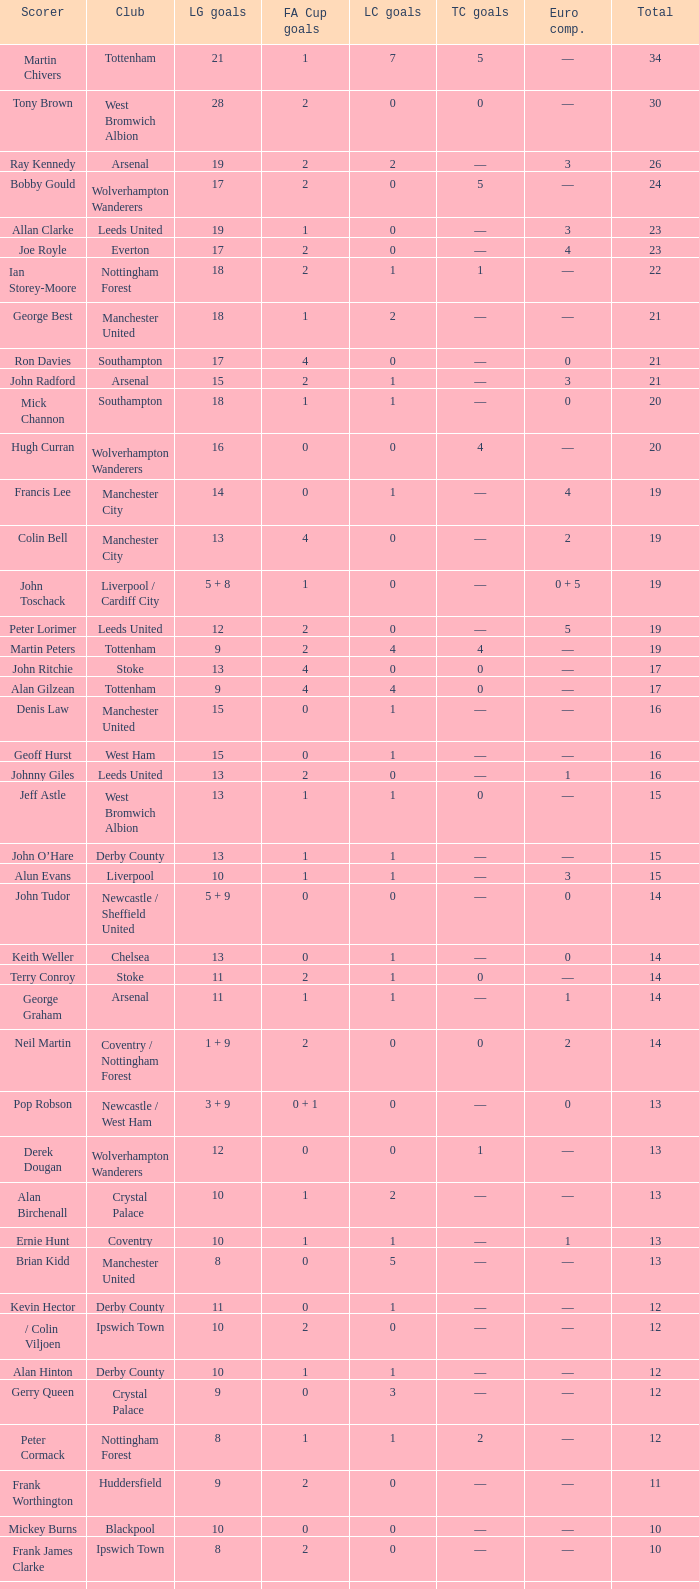Would you mind parsing the complete table? {'header': ['Scorer', 'Club', 'LG goals', 'FA Cup goals', 'LC goals', 'TC goals', 'Euro comp.', 'Total'], 'rows': [['Martin Chivers', 'Tottenham', '21', '1', '7', '5', '—', '34'], ['Tony Brown', 'West Bromwich Albion', '28', '2', '0', '0', '—', '30'], ['Ray Kennedy', 'Arsenal', '19', '2', '2', '—', '3', '26'], ['Bobby Gould', 'Wolverhampton Wanderers', '17', '2', '0', '5', '—', '24'], ['Allan Clarke', 'Leeds United', '19', '1', '0', '—', '3', '23'], ['Joe Royle', 'Everton', '17', '2', '0', '—', '4', '23'], ['Ian Storey-Moore', 'Nottingham Forest', '18', '2', '1', '1', '—', '22'], ['George Best', 'Manchester United', '18', '1', '2', '—', '—', '21'], ['Ron Davies', 'Southampton', '17', '4', '0', '—', '0', '21'], ['John Radford', 'Arsenal', '15', '2', '1', '—', '3', '21'], ['Mick Channon', 'Southampton', '18', '1', '1', '—', '0', '20'], ['Hugh Curran', 'Wolverhampton Wanderers', '16', '0', '0', '4', '—', '20'], ['Francis Lee', 'Manchester City', '14', '0', '1', '—', '4', '19'], ['Colin Bell', 'Manchester City', '13', '4', '0', '—', '2', '19'], ['John Toschack', 'Liverpool / Cardiff City', '5 + 8', '1', '0', '—', '0 + 5', '19'], ['Peter Lorimer', 'Leeds United', '12', '2', '0', '—', '5', '19'], ['Martin Peters', 'Tottenham', '9', '2', '4', '4', '—', '19'], ['John Ritchie', 'Stoke', '13', '4', '0', '0', '—', '17'], ['Alan Gilzean', 'Tottenham', '9', '4', '4', '0', '—', '17'], ['Denis Law', 'Manchester United', '15', '0', '1', '—', '—', '16'], ['Geoff Hurst', 'West Ham', '15', '0', '1', '—', '—', '16'], ['Johnny Giles', 'Leeds United', '13', '2', '0', '—', '1', '16'], ['Jeff Astle', 'West Bromwich Albion', '13', '1', '1', '0', '—', '15'], ['John O’Hare', 'Derby County', '13', '1', '1', '—', '—', '15'], ['Alun Evans', 'Liverpool', '10', '1', '1', '—', '3', '15'], ['John Tudor', 'Newcastle / Sheffield United', '5 + 9', '0', '0', '—', '0', '14'], ['Keith Weller', 'Chelsea', '13', '0', '1', '—', '0', '14'], ['Terry Conroy', 'Stoke', '11', '2', '1', '0', '—', '14'], ['George Graham', 'Arsenal', '11', '1', '1', '—', '1', '14'], ['Neil Martin', 'Coventry / Nottingham Forest', '1 + 9', '2', '0', '0', '2', '14'], ['Pop Robson', 'Newcastle / West Ham', '3 + 9', '0 + 1', '0', '—', '0', '13'], ['Derek Dougan', 'Wolverhampton Wanderers', '12', '0', '0', '1', '—', '13'], ['Alan Birchenall', 'Crystal Palace', '10', '1', '2', '—', '—', '13'], ['Ernie Hunt', 'Coventry', '10', '1', '1', '—', '1', '13'], ['Brian Kidd', 'Manchester United', '8', '0', '5', '—', '—', '13'], ['Kevin Hector', 'Derby County', '11', '0', '1', '—', '—', '12'], ['/ Colin Viljoen', 'Ipswich Town', '10', '2', '0', '—', '—', '12'], ['Alan Hinton', 'Derby County', '10', '1', '1', '—', '—', '12'], ['Gerry Queen', 'Crystal Palace', '9', '0', '3', '—', '—', '12'], ['Peter Cormack', 'Nottingham Forest', '8', '1', '1', '2', '—', '12'], ['Frank Worthington', 'Huddersfield', '9', '2', '0', '—', '—', '11'], ['Mickey Burns', 'Blackpool', '10', '0', '0', '—', '—', '10'], ['Frank James Clarke', 'Ipswich Town', '8', '2', '0', '—', '—', '10'], ['Jimmy Greenhoff', 'Stoke', '7', '3', '0', '0', '—', '10'], ['Charlie George', 'Arsenal', '5', '5', '0', '—', '0', '10']]} What is the total number of Total, when Club is Leeds United, and when League Goals is 13? 1.0. 